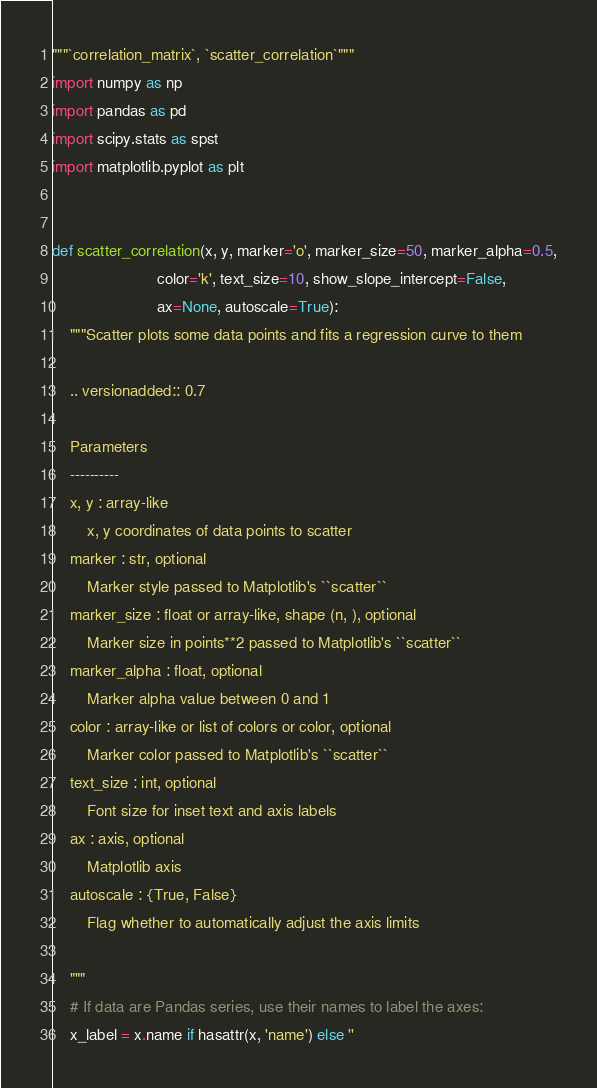Convert code to text. <code><loc_0><loc_0><loc_500><loc_500><_Python_>"""`correlation_matrix`, `scatter_correlation`"""
import numpy as np
import pandas as pd
import scipy.stats as spst
import matplotlib.pyplot as plt


def scatter_correlation(x, y, marker='o', marker_size=50, marker_alpha=0.5,
                        color='k', text_size=10, show_slope_intercept=False,
                        ax=None, autoscale=True):
    """Scatter plots some data points and fits a regression curve to them

    .. versionadded:: 0.7

    Parameters
    ----------
    x, y : array-like
        x, y coordinates of data points to scatter
    marker : str, optional
        Marker style passed to Matplotlib's ``scatter``
    marker_size : float or array-like, shape (n, ), optional
        Marker size in points**2 passed to Matplotlib's ``scatter``
    marker_alpha : float, optional
        Marker alpha value between 0 and 1
    color : array-like or list of colors or color, optional
        Marker color passed to Matplotlib's ``scatter``
    text_size : int, optional
        Font size for inset text and axis labels
    ax : axis, optional
        Matplotlib axis
    autoscale : {True, False}
        Flag whether to automatically adjust the axis limits

    """
    # If data are Pandas series, use their names to label the axes:
    x_label = x.name if hasattr(x, 'name') else ''</code> 